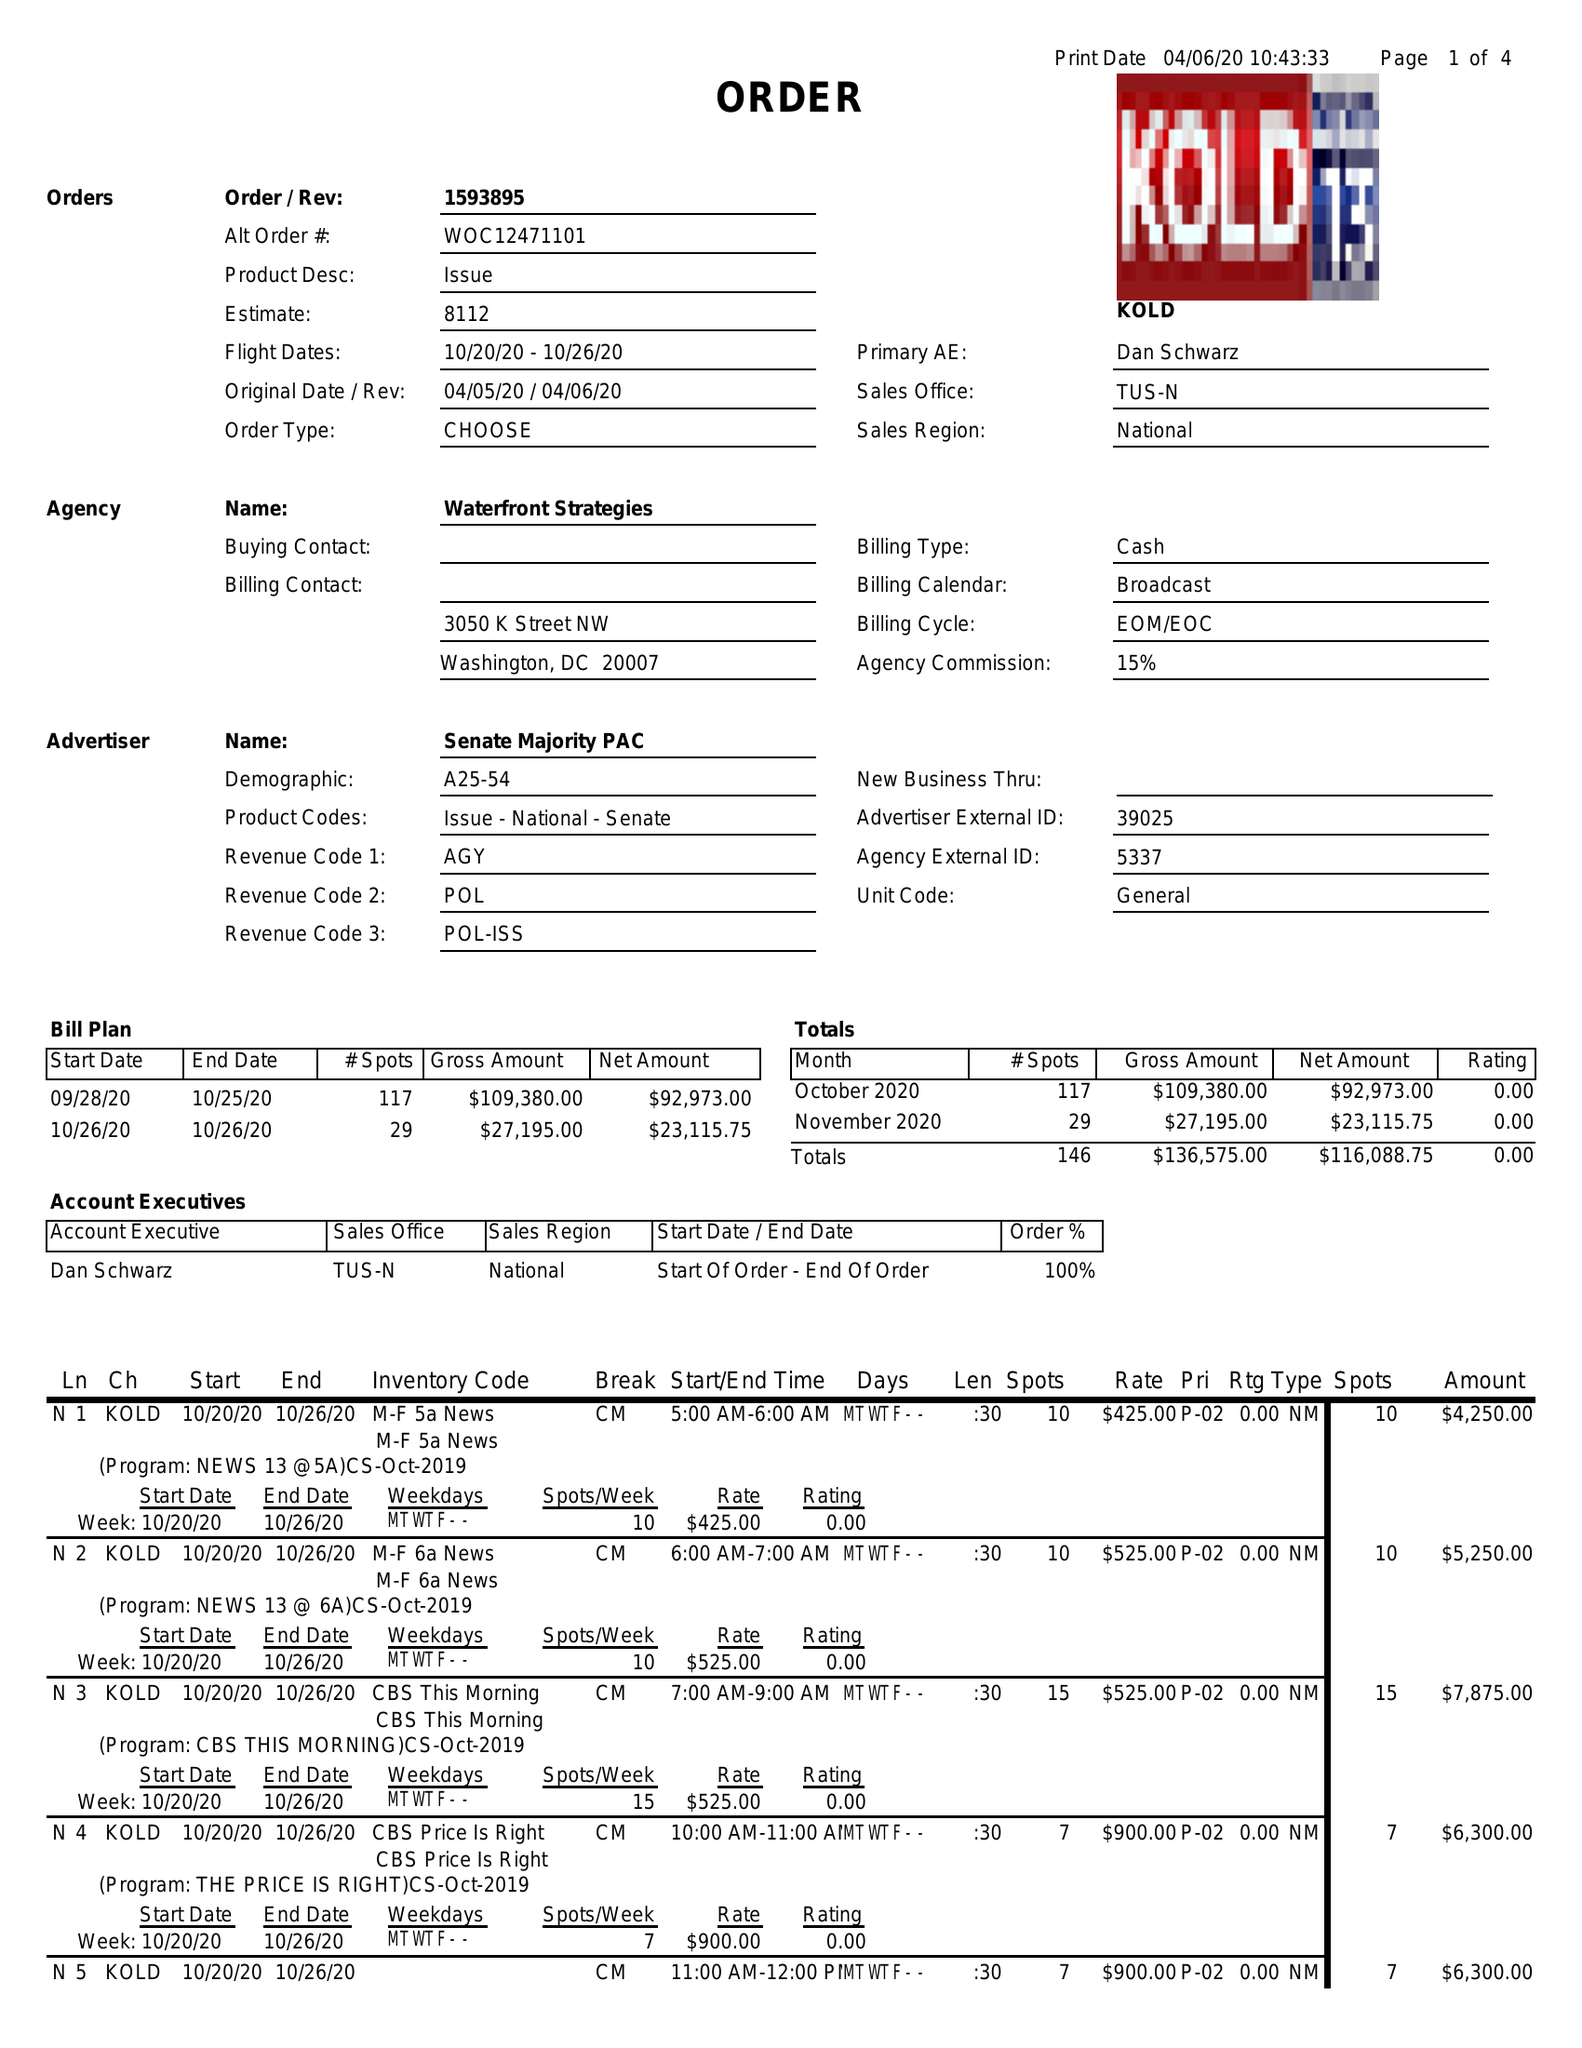What is the value for the gross_amount?
Answer the question using a single word or phrase. 136575.00 